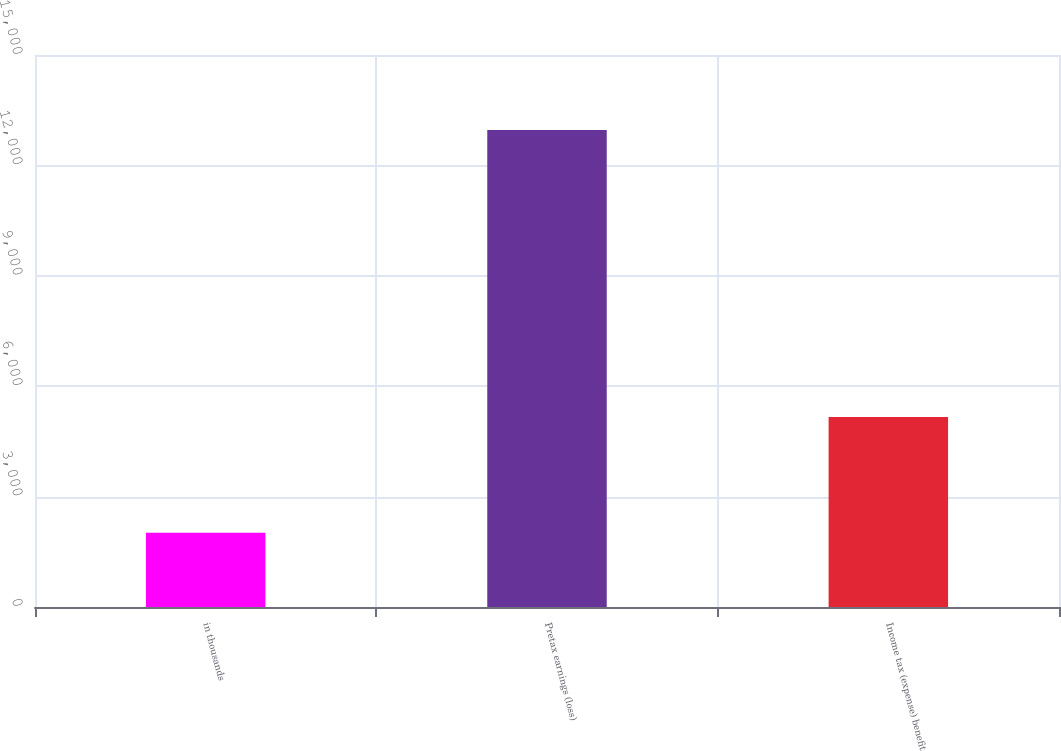<chart> <loc_0><loc_0><loc_500><loc_500><bar_chart><fcel>in thousands<fcel>Pretax earnings (loss)<fcel>Income tax (expense) benefit<nl><fcel>2017<fcel>12959<fcel>5165<nl></chart> 